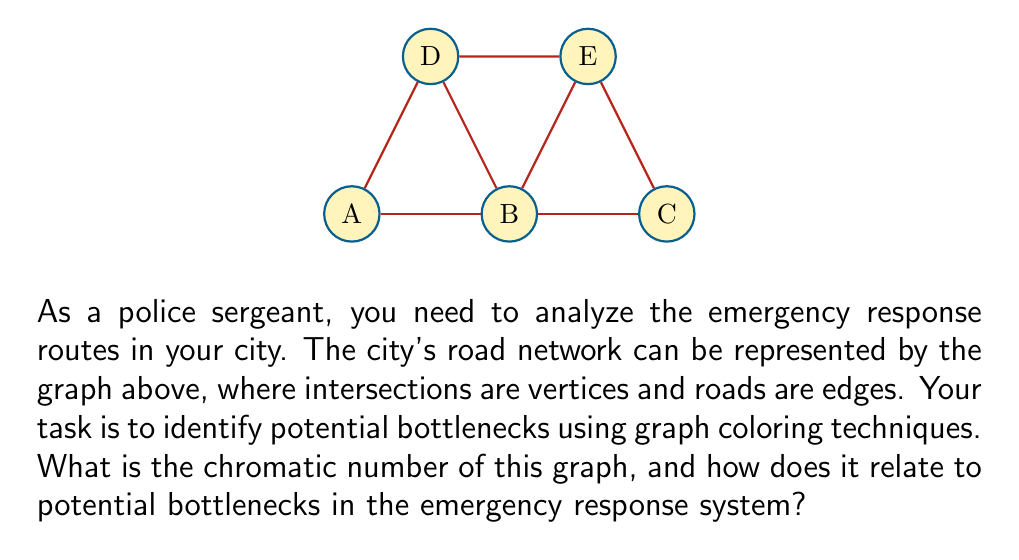Can you answer this question? To solve this problem, we'll follow these steps:

1) First, let's understand what the chromatic number means in this context:
   - The chromatic number is the minimum number of colors needed to color the vertices of a graph such that no two adjacent vertices have the same color.
   - In our emergency response system, colors represent different time slots or channels for emergency vehicles to pass through intersections.

2) Now, let's color the graph:
   - Start with vertex A. We can color it with color 1.
   - B is adjacent to A, so it needs a different color. Color it with color 2.
   - C is adjacent to B, so it needs a new color. Color it with color 3.
   - D is adjacent to A and B, so it needs a new color. Color it with color 3.
   - E is adjacent to B, C, and D, so it needs a new color. Color it with color 4.

3) We've used 4 colors, and it's not possible to use fewer. Therefore, the chromatic number is 4.

4) Interpretation for emergency response:
   - The chromatic number of 4 indicates that we need at least 4 different time slots or channels to manage traffic at these intersections without conflicts.
   - A higher chromatic number suggests more potential for bottlenecks, as it requires more coordination to manage traffic flow.
   - In this case, intersection E is a critical point, as it requires a unique fourth color. This suggests that E could be a potential bottleneck in the emergency response system.

5) Bottleneck analysis:
   - Intersection E is connected to three other intersections (B, C, and D), making it a high-traffic node.
   - In an emergency, vehicles may need to wait longer at E to avoid conflicts with other emergency vehicles.
   - This could lead to delays in response times, especially if multiple emergencies occur simultaneously in different parts of the city.

Therefore, the chromatic number of 4, particularly due to intersection E, indicates a potential bottleneck in the emergency response routes.
Answer: Chromatic number: 4. Potential bottleneck: Intersection E. 